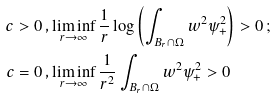Convert formula to latex. <formula><loc_0><loc_0><loc_500><loc_500>\, c > 0 \, , & \liminf _ { r \to \infty } \frac { 1 } { r } \log \left ( \int _ { B _ { r } \cap \Omega } w ^ { 2 } \psi _ { + } ^ { 2 } \right ) > 0 \, ; \\ \, c = 0 \, , & \liminf _ { r \to \infty } \frac { 1 } { r ^ { 2 } } \int _ { B _ { r } \cap \Omega } w ^ { 2 } \psi _ { + } ^ { 2 } > 0</formula> 